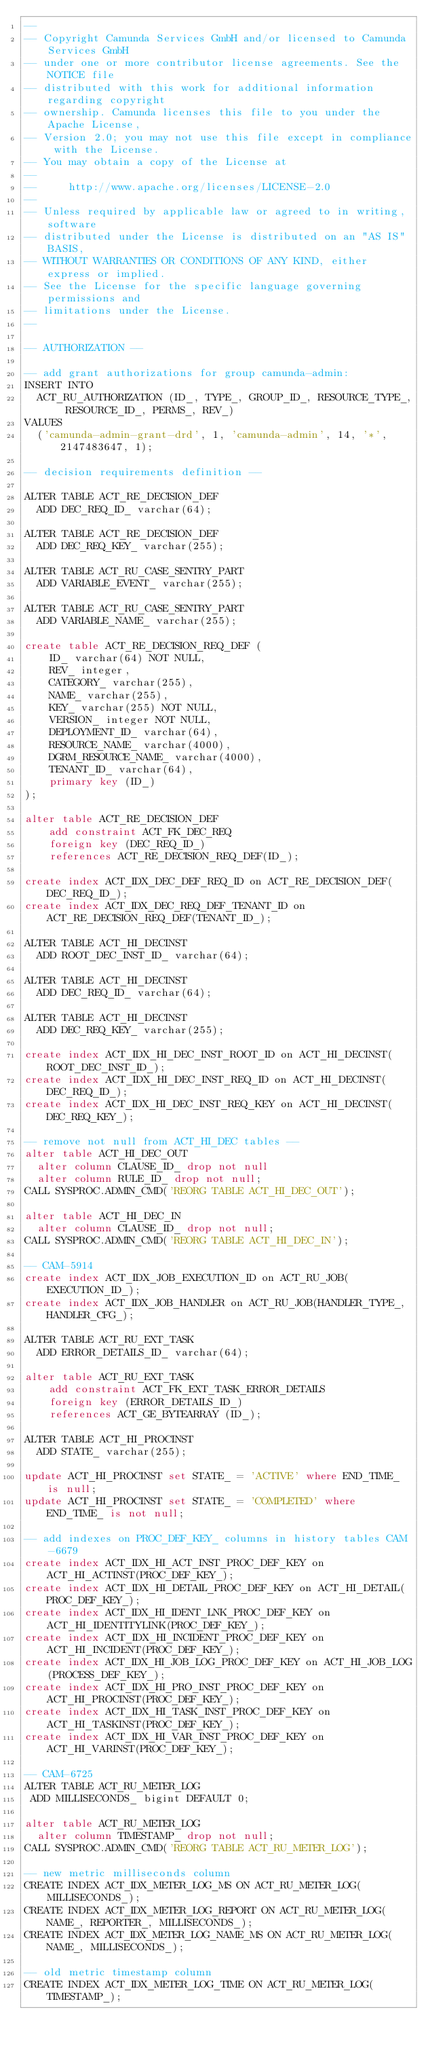<code> <loc_0><loc_0><loc_500><loc_500><_SQL_>--
-- Copyright Camunda Services GmbH and/or licensed to Camunda Services GmbH
-- under one or more contributor license agreements. See the NOTICE file
-- distributed with this work for additional information regarding copyright
-- ownership. Camunda licenses this file to you under the Apache License,
-- Version 2.0; you may not use this file except in compliance with the License.
-- You may obtain a copy of the License at
--
--     http://www.apache.org/licenses/LICENSE-2.0
--
-- Unless required by applicable law or agreed to in writing, software
-- distributed under the License is distributed on an "AS IS" BASIS,
-- WITHOUT WARRANTIES OR CONDITIONS OF ANY KIND, either express or implied.
-- See the License for the specific language governing permissions and
-- limitations under the License.
--

-- AUTHORIZATION --

-- add grant authorizations for group camunda-admin:
INSERT INTO
  ACT_RU_AUTHORIZATION (ID_, TYPE_, GROUP_ID_, RESOURCE_TYPE_, RESOURCE_ID_, PERMS_, REV_)
VALUES
  ('camunda-admin-grant-drd', 1, 'camunda-admin', 14, '*', 2147483647, 1);

-- decision requirements definition --

ALTER TABLE ACT_RE_DECISION_DEF
  ADD DEC_REQ_ID_ varchar(64);

ALTER TABLE ACT_RE_DECISION_DEF
  ADD DEC_REQ_KEY_ varchar(255);

ALTER TABLE ACT_RU_CASE_SENTRY_PART
  ADD VARIABLE_EVENT_ varchar(255);

ALTER TABLE ACT_RU_CASE_SENTRY_PART
  ADD VARIABLE_NAME_ varchar(255);

create table ACT_RE_DECISION_REQ_DEF (
    ID_ varchar(64) NOT NULL,
    REV_ integer,
    CATEGORY_ varchar(255),
    NAME_ varchar(255),
    KEY_ varchar(255) NOT NULL,
    VERSION_ integer NOT NULL,
    DEPLOYMENT_ID_ varchar(64),
    RESOURCE_NAME_ varchar(4000),
    DGRM_RESOURCE_NAME_ varchar(4000),
    TENANT_ID_ varchar(64),
    primary key (ID_)
);

alter table ACT_RE_DECISION_DEF
    add constraint ACT_FK_DEC_REQ
    foreign key (DEC_REQ_ID_)
    references ACT_RE_DECISION_REQ_DEF(ID_);

create index ACT_IDX_DEC_DEF_REQ_ID on ACT_RE_DECISION_DEF(DEC_REQ_ID_);
create index ACT_IDX_DEC_REQ_DEF_TENANT_ID on ACT_RE_DECISION_REQ_DEF(TENANT_ID_);

ALTER TABLE ACT_HI_DECINST
  ADD ROOT_DEC_INST_ID_ varchar(64);

ALTER TABLE ACT_HI_DECINST
  ADD DEC_REQ_ID_ varchar(64);

ALTER TABLE ACT_HI_DECINST
  ADD DEC_REQ_KEY_ varchar(255);

create index ACT_IDX_HI_DEC_INST_ROOT_ID on ACT_HI_DECINST(ROOT_DEC_INST_ID_);
create index ACT_IDX_HI_DEC_INST_REQ_ID on ACT_HI_DECINST(DEC_REQ_ID_);
create index ACT_IDX_HI_DEC_INST_REQ_KEY on ACT_HI_DECINST(DEC_REQ_KEY_);

-- remove not null from ACT_HI_DEC tables --
alter table ACT_HI_DEC_OUT
  alter column CLAUSE_ID_ drop not null
  alter column RULE_ID_ drop not null;
CALL SYSPROC.ADMIN_CMD('REORG TABLE ACT_HI_DEC_OUT');

alter table ACT_HI_DEC_IN
  alter column CLAUSE_ID_ drop not null;
CALL SYSPROC.ADMIN_CMD('REORG TABLE ACT_HI_DEC_IN');

-- CAM-5914
create index ACT_IDX_JOB_EXECUTION_ID on ACT_RU_JOB(EXECUTION_ID_);
create index ACT_IDX_JOB_HANDLER on ACT_RU_JOB(HANDLER_TYPE_,HANDLER_CFG_);

ALTER TABLE ACT_RU_EXT_TASK
  ADD ERROR_DETAILS_ID_ varchar(64);

alter table ACT_RU_EXT_TASK
    add constraint ACT_FK_EXT_TASK_ERROR_DETAILS
    foreign key (ERROR_DETAILS_ID_)
    references ACT_GE_BYTEARRAY (ID_);

ALTER TABLE ACT_HI_PROCINST
  ADD STATE_ varchar(255);

update ACT_HI_PROCINST set STATE_ = 'ACTIVE' where END_TIME_ is null;
update ACT_HI_PROCINST set STATE_ = 'COMPLETED' where END_TIME_ is not null;

-- add indexes on PROC_DEF_KEY_ columns in history tables CAM-6679
create index ACT_IDX_HI_ACT_INST_PROC_DEF_KEY on ACT_HI_ACTINST(PROC_DEF_KEY_);
create index ACT_IDX_HI_DETAIL_PROC_DEF_KEY on ACT_HI_DETAIL(PROC_DEF_KEY_);
create index ACT_IDX_HI_IDENT_LNK_PROC_DEF_KEY on ACT_HI_IDENTITYLINK(PROC_DEF_KEY_);
create index ACT_IDX_HI_INCIDENT_PROC_DEF_KEY on ACT_HI_INCIDENT(PROC_DEF_KEY_);
create index ACT_IDX_HI_JOB_LOG_PROC_DEF_KEY on ACT_HI_JOB_LOG(PROCESS_DEF_KEY_);
create index ACT_IDX_HI_PRO_INST_PROC_DEF_KEY on ACT_HI_PROCINST(PROC_DEF_KEY_);
create index ACT_IDX_HI_TASK_INST_PROC_DEF_KEY on ACT_HI_TASKINST(PROC_DEF_KEY_);
create index ACT_IDX_HI_VAR_INST_PROC_DEF_KEY on ACT_HI_VARINST(PROC_DEF_KEY_);

-- CAM-6725
ALTER TABLE ACT_RU_METER_LOG
 ADD MILLISECONDS_ bigint DEFAULT 0;

alter table ACT_RU_METER_LOG
  alter column TIMESTAMP_ drop not null;
CALL SYSPROC.ADMIN_CMD('REORG TABLE ACT_RU_METER_LOG');

-- new metric milliseconds column
CREATE INDEX ACT_IDX_METER_LOG_MS ON ACT_RU_METER_LOG(MILLISECONDS_);
CREATE INDEX ACT_IDX_METER_LOG_REPORT ON ACT_RU_METER_LOG(NAME_, REPORTER_, MILLISECONDS_);
CREATE INDEX ACT_IDX_METER_LOG_NAME_MS ON ACT_RU_METER_LOG(NAME_, MILLISECONDS_);

-- old metric timestamp column
CREATE INDEX ACT_IDX_METER_LOG_TIME ON ACT_RU_METER_LOG(TIMESTAMP_);
</code> 